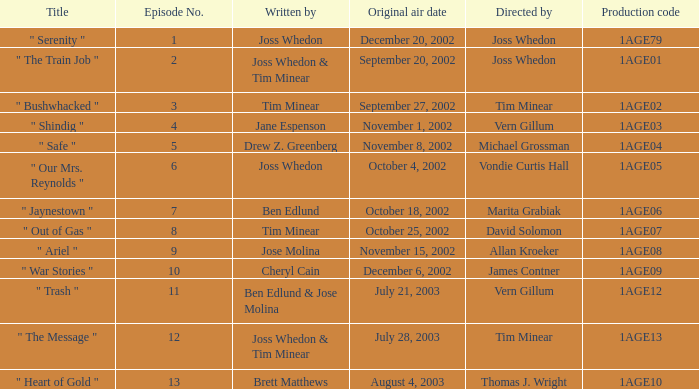What is the production code for the episode written by Drew Z. Greenberg? 1AGE04. 